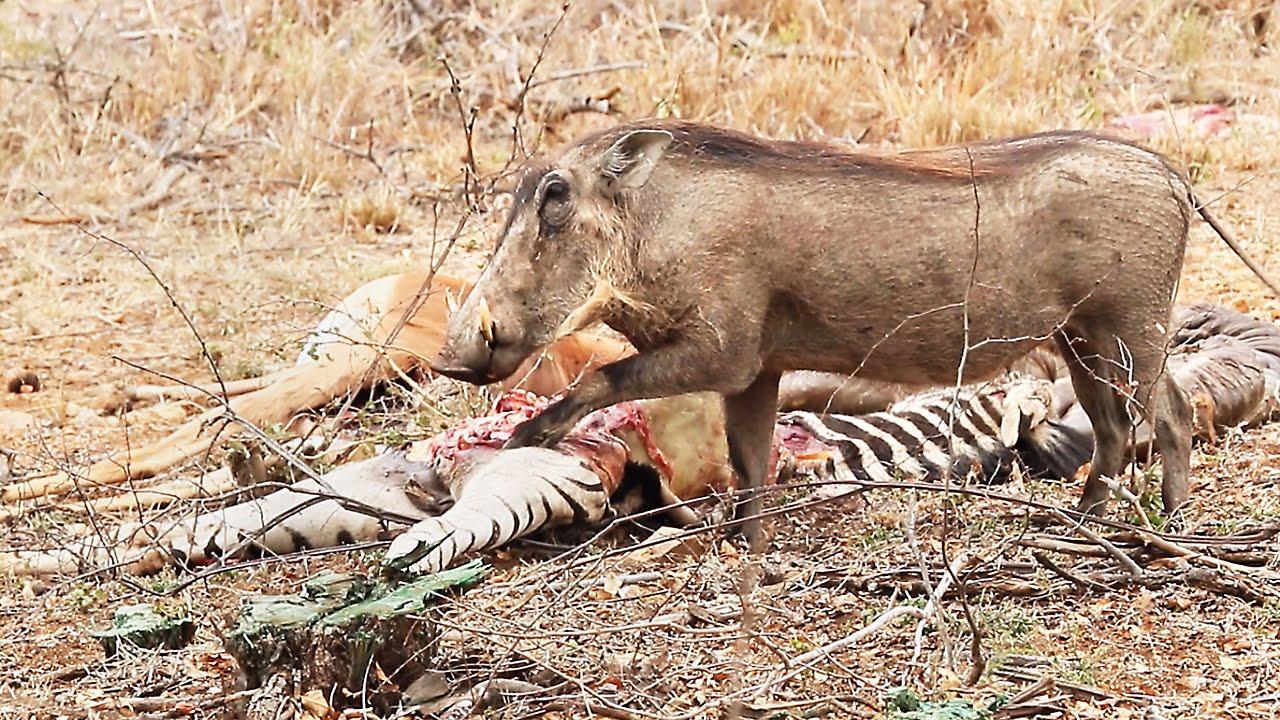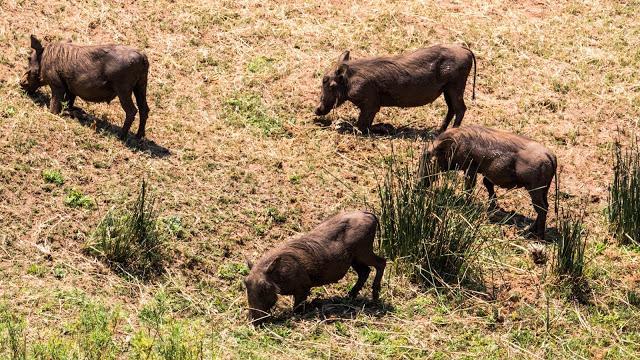The first image is the image on the left, the second image is the image on the right. Examine the images to the left and right. Is the description "warthogs are sitting on bent front legs" accurate? Answer yes or no. No. The first image is the image on the left, the second image is the image on the right. Evaluate the accuracy of this statement regarding the images: "A group of four or more animals stands in a field.". Is it true? Answer yes or no. Yes. 